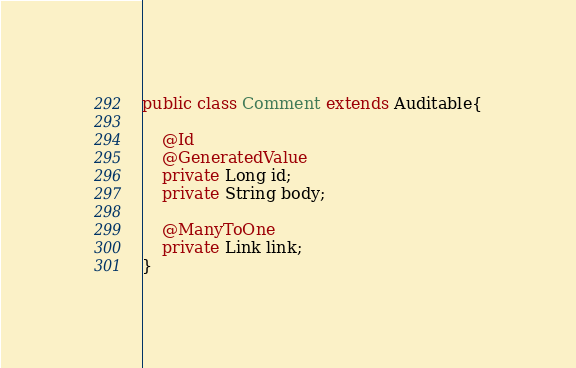<code> <loc_0><loc_0><loc_500><loc_500><_Java_>public class Comment extends Auditable{

    @Id
    @GeneratedValue
    private Long id;
    private String body;

    @ManyToOne
    private Link link;
}
</code> 